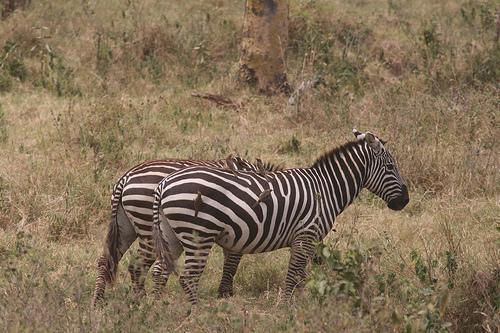How many zebras?
Give a very brief answer. 2. How many zebras are there?
Give a very brief answer. 2. How many zebra tails are in the picture?
Give a very brief answer. 2. How many birds are on the zebra?
Give a very brief answer. 4. How many zebra heads can be seen?
Give a very brief answer. 1. How many different types of animals are pictured here?
Give a very brief answer. 2. How many zebras are in the photo?
Give a very brief answer. 2. How many zebras are facing the camera?
Give a very brief answer. 0. How many trees are in the photo?
Give a very brief answer. 1. How many zebras are in the photo?
Give a very brief answer. 2. 